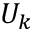<formula> <loc_0><loc_0><loc_500><loc_500>U _ { k }</formula> 